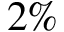<formula> <loc_0><loc_0><loc_500><loc_500>2 \%</formula> 